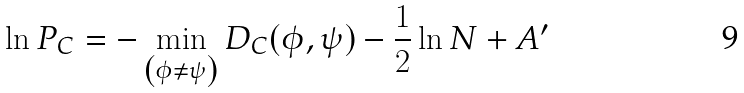<formula> <loc_0><loc_0><loc_500><loc_500>\ln P _ { C } = - \min _ { \left ( \phi \neq \psi \right ) } D _ { C } ( \phi , \psi ) - \frac { 1 } { 2 } \ln N + A ^ { \prime }</formula> 